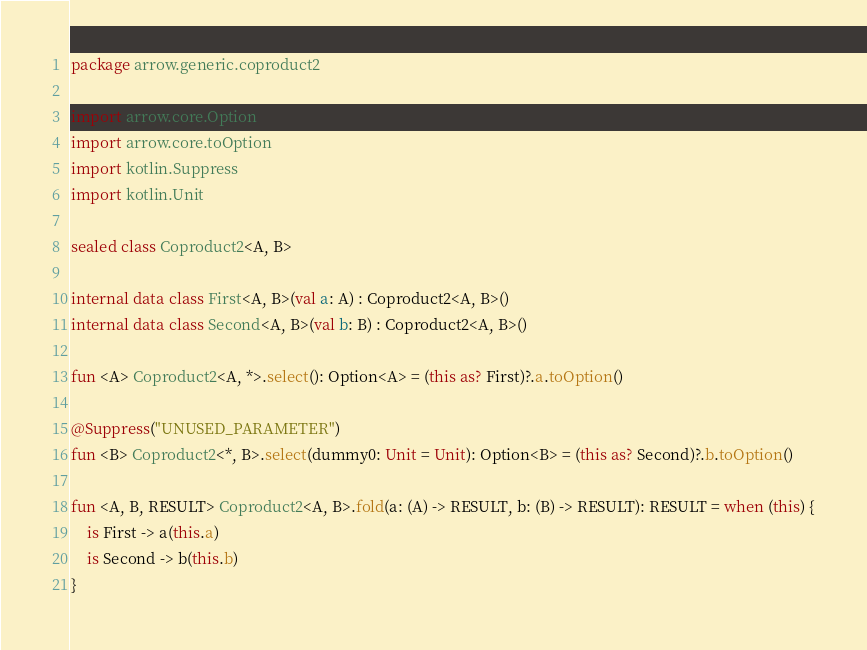<code> <loc_0><loc_0><loc_500><loc_500><_Kotlin_>package arrow.generic.coproduct2

import arrow.core.Option
import arrow.core.toOption
import kotlin.Suppress
import kotlin.Unit

sealed class Coproduct2<A, B>

internal data class First<A, B>(val a: A) : Coproduct2<A, B>()
internal data class Second<A, B>(val b: B) : Coproduct2<A, B>()

fun <A> Coproduct2<A, *>.select(): Option<A> = (this as? First)?.a.toOption()

@Suppress("UNUSED_PARAMETER")
fun <B> Coproduct2<*, B>.select(dummy0: Unit = Unit): Option<B> = (this as? Second)?.b.toOption()

fun <A, B, RESULT> Coproduct2<A, B>.fold(a: (A) -> RESULT, b: (B) -> RESULT): RESULT = when (this) {
    is First -> a(this.a)
    is Second -> b(this.b)
}
</code> 